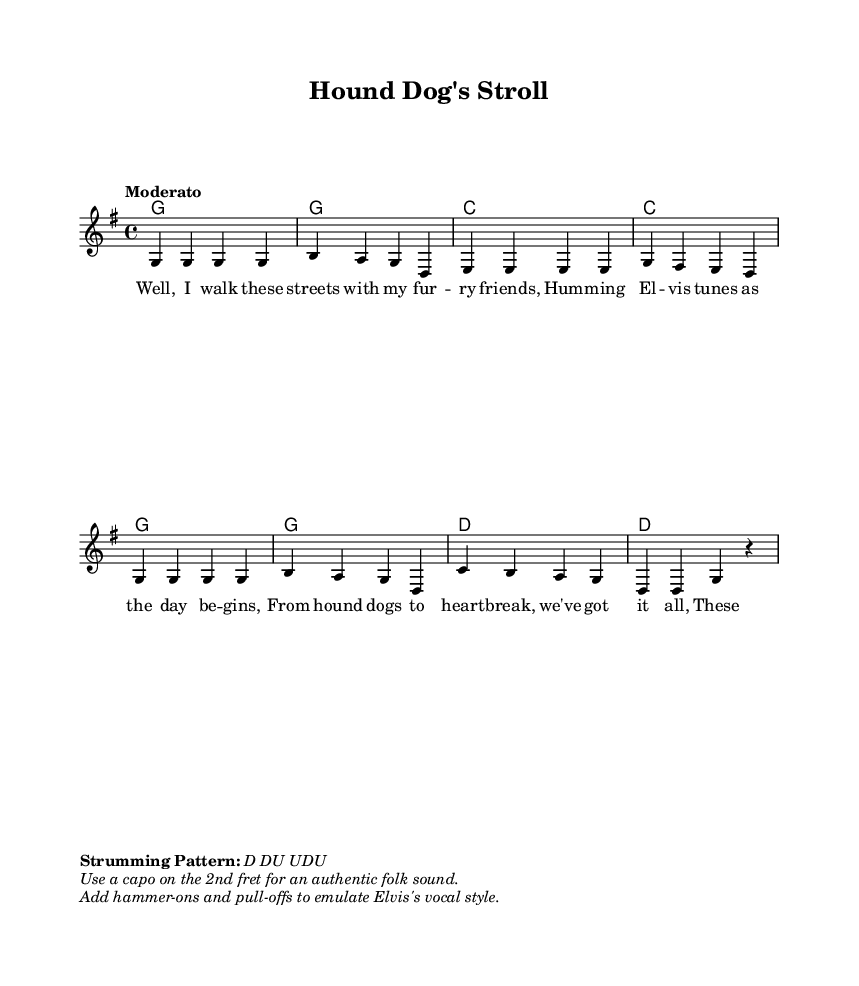What is the key signature of this music? The key signature is G major, which has one sharp (F♯). This can be identified by looking at the key signature indicated at the beginning of the sheet music.
Answer: G major What is the time signature of this piece? The time signature is 4/4, which means there are four beats in each measure. This is visible in the beginning of the sheet music.
Answer: 4/4 What is the tempo marking for this piece? The tempo marking is "Moderato," which indicates a moderate speed. It is specified at the beginning of the score.
Answer: Moderato How many measures are in the melody? There are eight measures in the melody, which can be counted by looking at the notation. Each line consists of four measures, and there are two lines.
Answer: Eight What strumming pattern is suggested for this piece? The strumming pattern suggested is "D DU UDU," as stated in the markup at the bottom of the sheet music.
Answer: D DU UDU What should be used to achieve an authentic folk sound? A capo on the 2nd fret should be used, which is mentioned in the additional markups. This will help in achieving the desired sound for folk music.
Answer: Capo on the 2nd fret What musical technique can be added to emulate Elvis's vocal style? Hammer-ons and pull-offs can be added, as indicated in the markup. This technique mimics the expressive style of Elvis's vocals.
Answer: Hammer-ons and pull-offs 